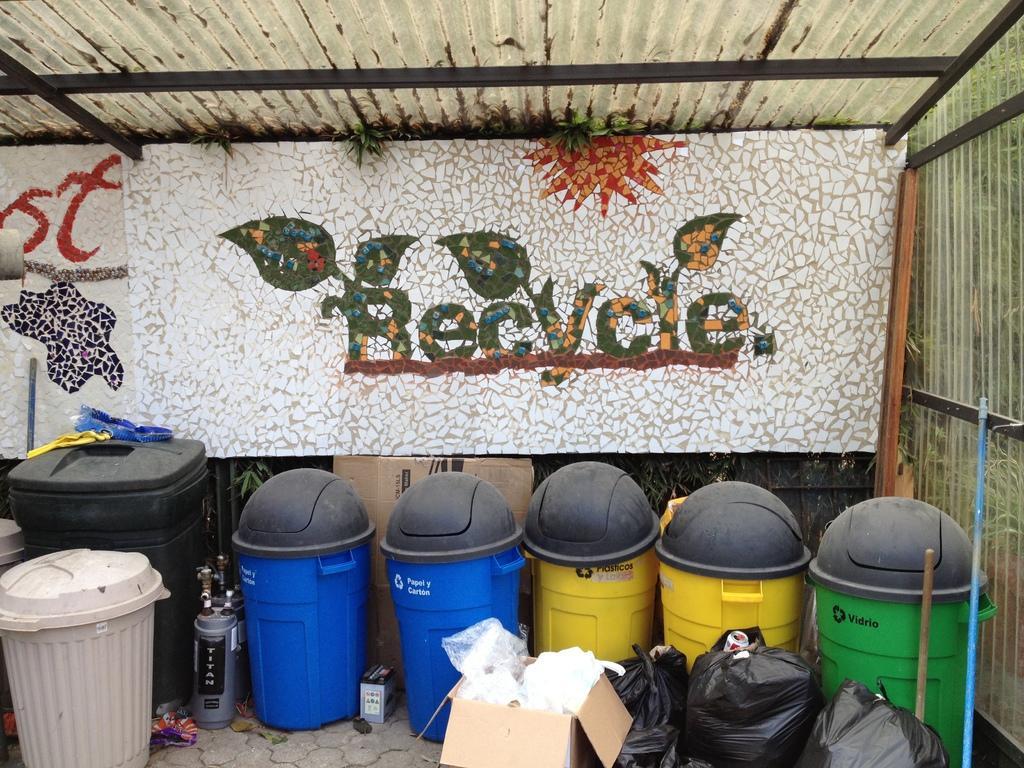Describe this image in one or two sentences. In this image there are waste containers, cardboard boxes, cylinders and covers on the ground. Behind them there is a wall. There is a board hanging on the wall. There is text on the board. At the top there is a ceiling. To the right there are sticks. 